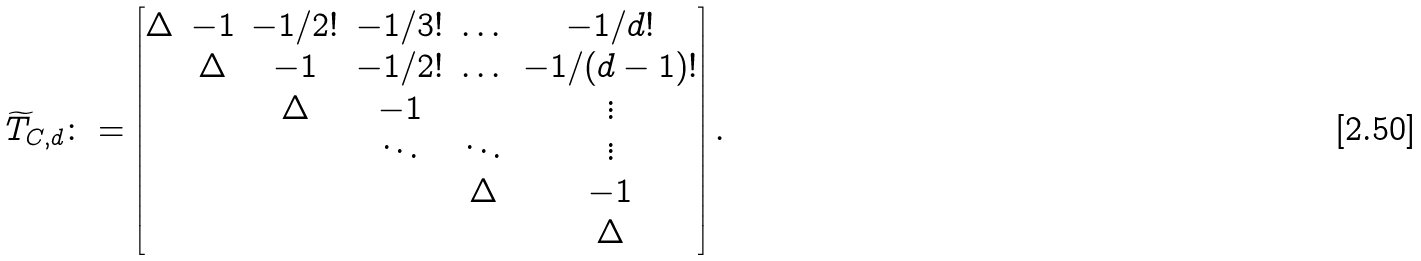<formula> <loc_0><loc_0><loc_500><loc_500>\widetilde { T } _ { C , d } \colon = \begin{bmatrix} \Delta & - 1 & - 1 / 2 ! & - 1 / 3 ! & \dots & - 1 / d ! \\ & \Delta & - 1 & - 1 / 2 ! & \dots & - 1 / ( d - 1 ) ! \\ & & \Delta & - 1 & & \vdots \\ & & & \ddots & \ddots & \vdots \\ & & & & \Delta & - 1 \\ & & & & & \Delta \end{bmatrix} .</formula> 